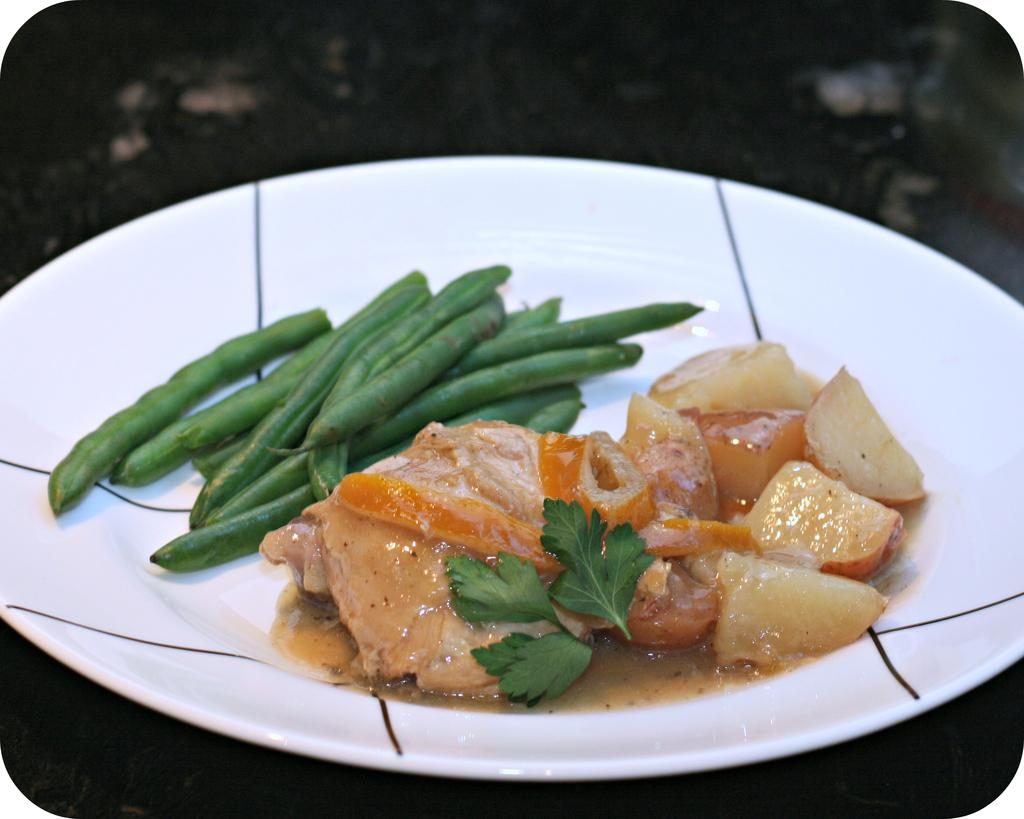What is on the plate that is visible in the image? The plate has beans on it. What else can be seen on the plate besides beans? There is food and leaves on the plate. What color is the crayon on the plate? There is no crayon present on the plate in the image. How is the coat arranged on the plate? There is no coat present on the plate in the image. 